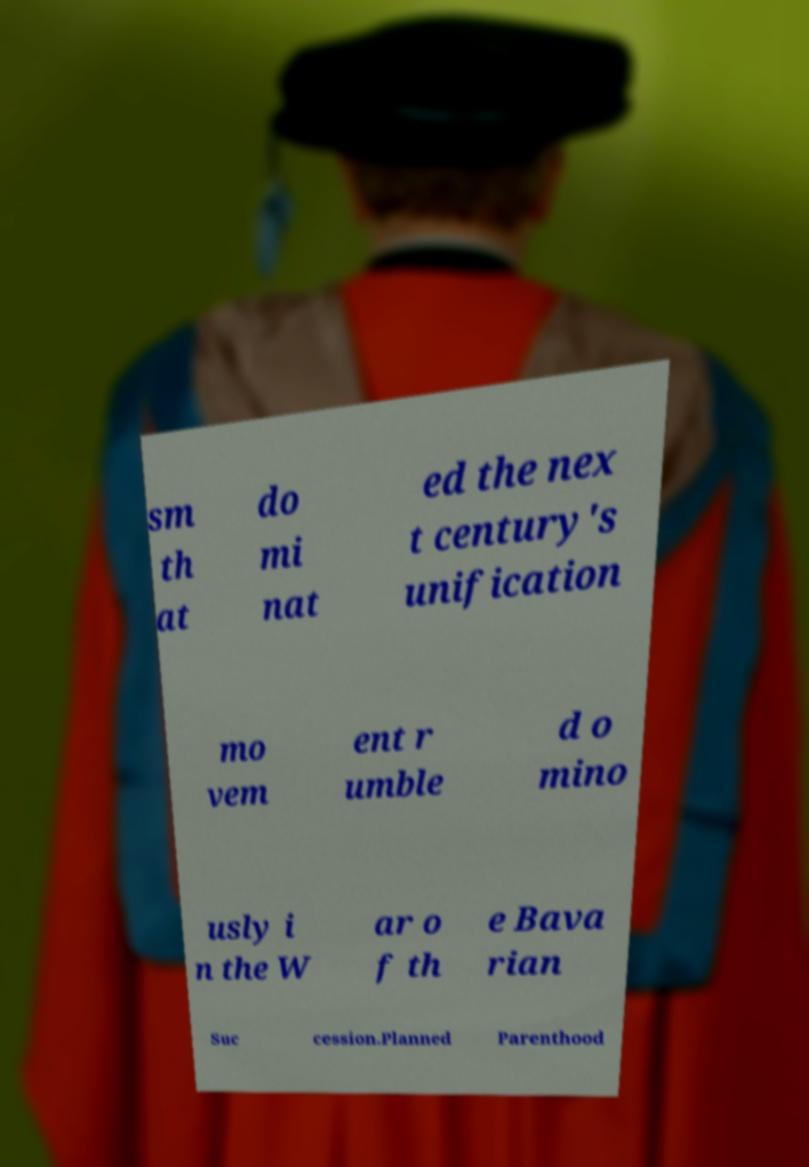What messages or text are displayed in this image? I need them in a readable, typed format. sm th at do mi nat ed the nex t century's unification mo vem ent r umble d o mino usly i n the W ar o f th e Bava rian Suc cession.Planned Parenthood 